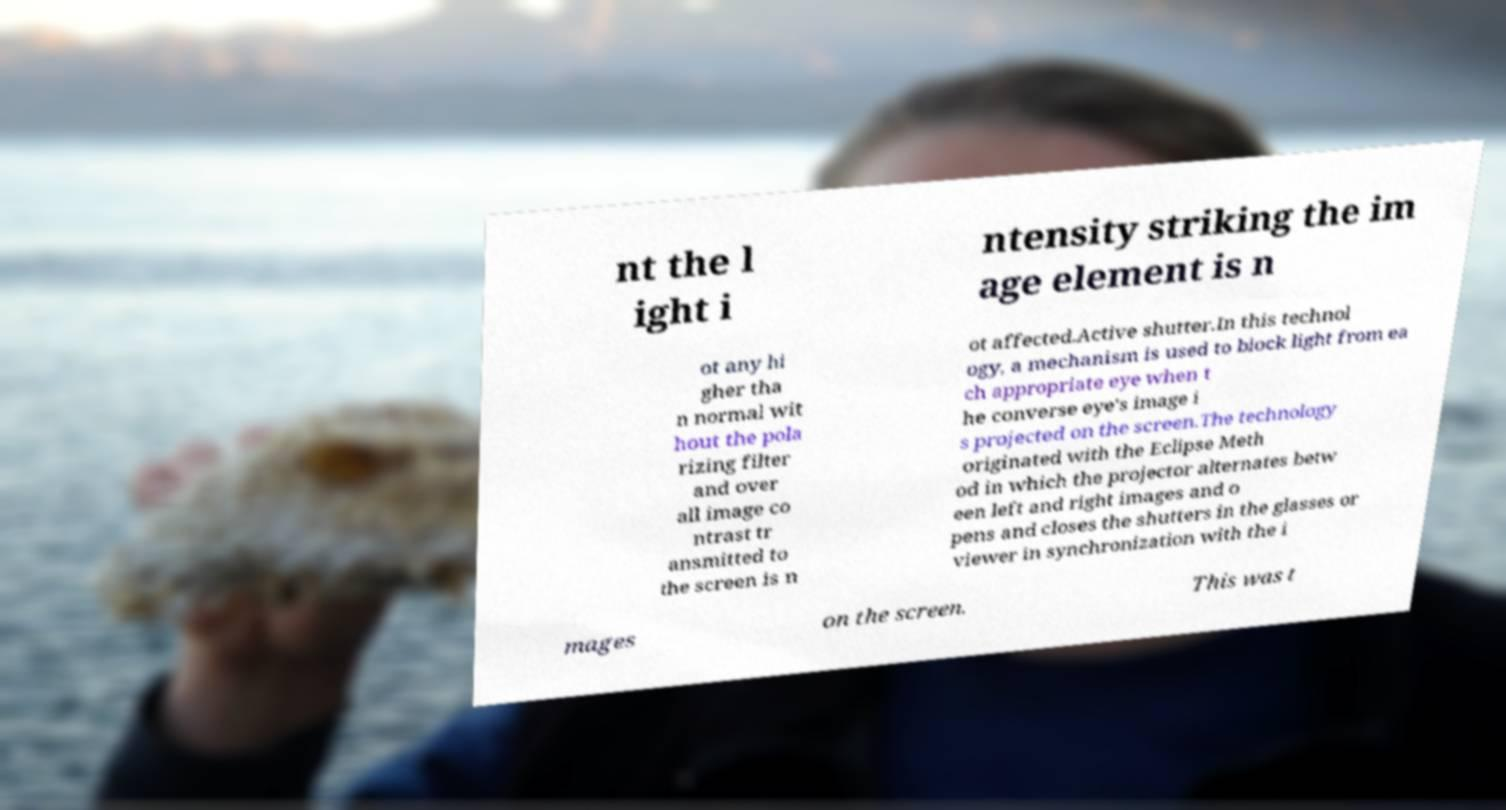Could you assist in decoding the text presented in this image and type it out clearly? nt the l ight i ntensity striking the im age element is n ot any hi gher tha n normal wit hout the pola rizing filter and over all image co ntrast tr ansmitted to the screen is n ot affected.Active shutter.In this technol ogy, a mechanism is used to block light from ea ch appropriate eye when t he converse eye's image i s projected on the screen.The technology originated with the Eclipse Meth od in which the projector alternates betw een left and right images and o pens and closes the shutters in the glasses or viewer in synchronization with the i mages on the screen. This was t 